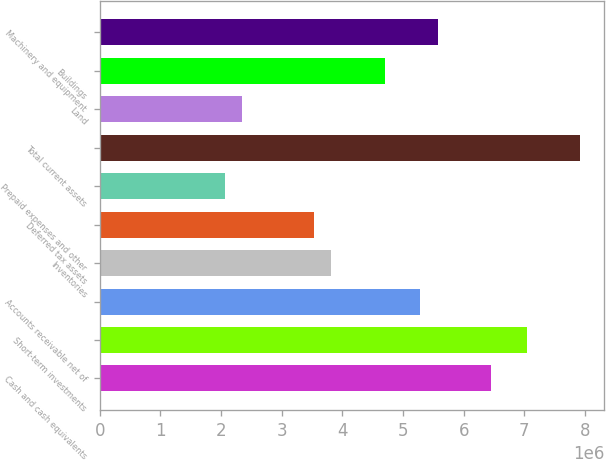<chart> <loc_0><loc_0><loc_500><loc_500><bar_chart><fcel>Cash and cash equivalents<fcel>Short-term investments<fcel>Accounts receivable net of<fcel>Inventories<fcel>Deferred tax assets<fcel>Prepaid expenses and other<fcel>Total current assets<fcel>Land<fcel>Buildings<fcel>Machinery and equipment<nl><fcel>6.45828e+06<fcel>7.04508e+06<fcel>5.28468e+06<fcel>3.81767e+06<fcel>3.52427e+06<fcel>2.05727e+06<fcel>7.92528e+06<fcel>2.35067e+06<fcel>4.69787e+06<fcel>5.57808e+06<nl></chart> 